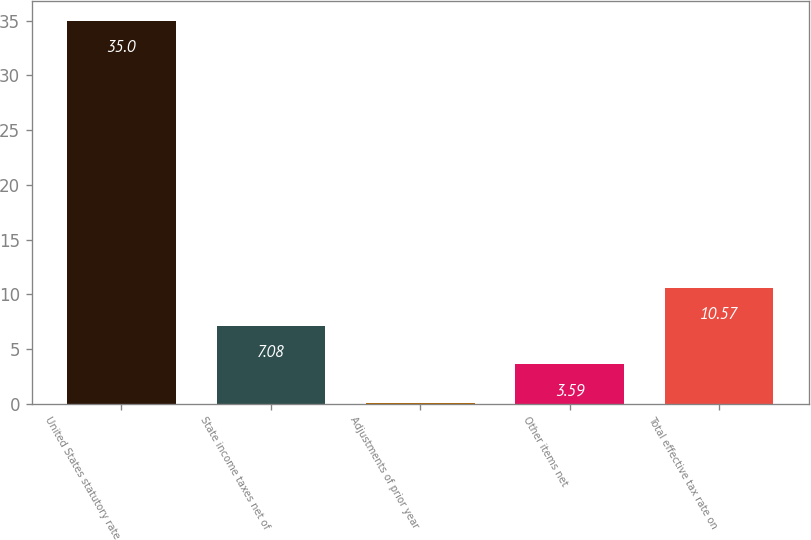<chart> <loc_0><loc_0><loc_500><loc_500><bar_chart><fcel>United States statutory rate<fcel>State income taxes net of<fcel>Adjustments of prior year<fcel>Other items net<fcel>Total effective tax rate on<nl><fcel>35<fcel>7.08<fcel>0.1<fcel>3.59<fcel>10.57<nl></chart> 